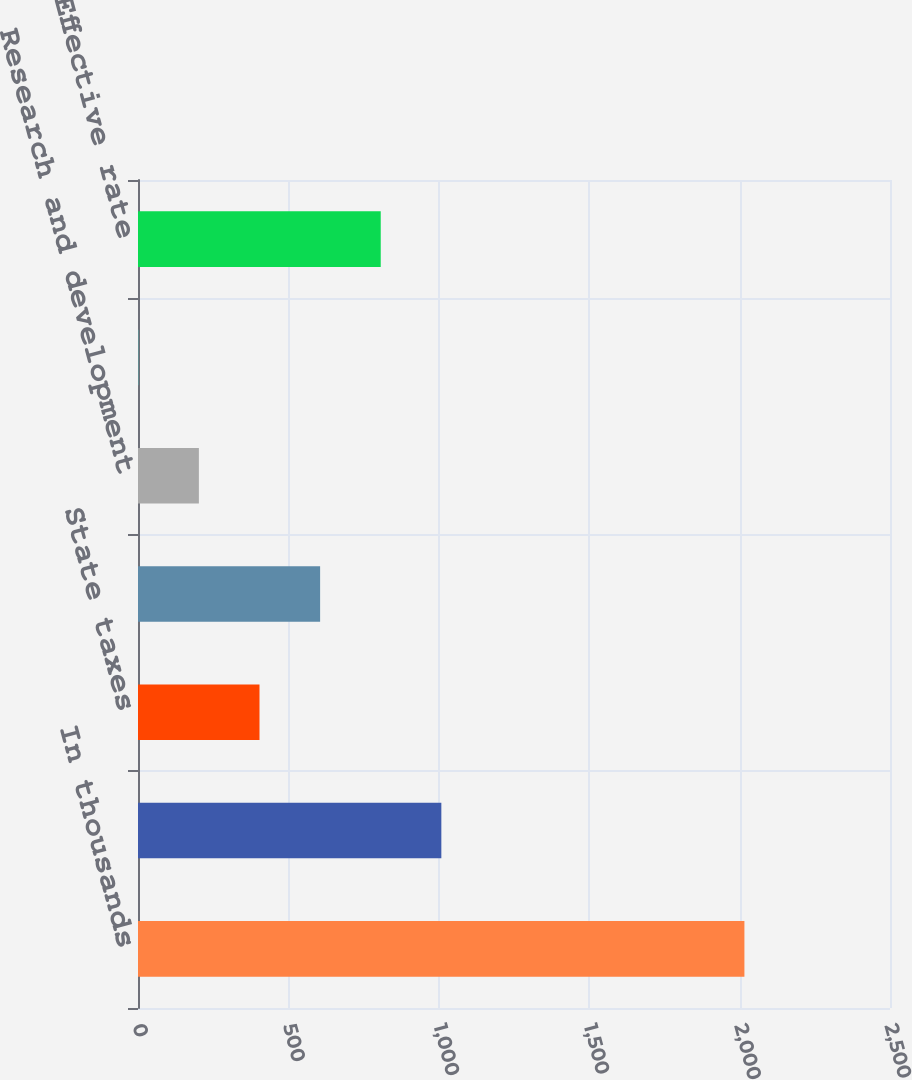<chart> <loc_0><loc_0><loc_500><loc_500><bar_chart><fcel>In thousands<fcel>US federal statutory rate<fcel>State taxes<fcel>Foreign<fcel>Research and development<fcel>Other net<fcel>Effective rate<nl><fcel>2016<fcel>1008.45<fcel>403.92<fcel>605.43<fcel>202.41<fcel>0.9<fcel>806.94<nl></chart> 